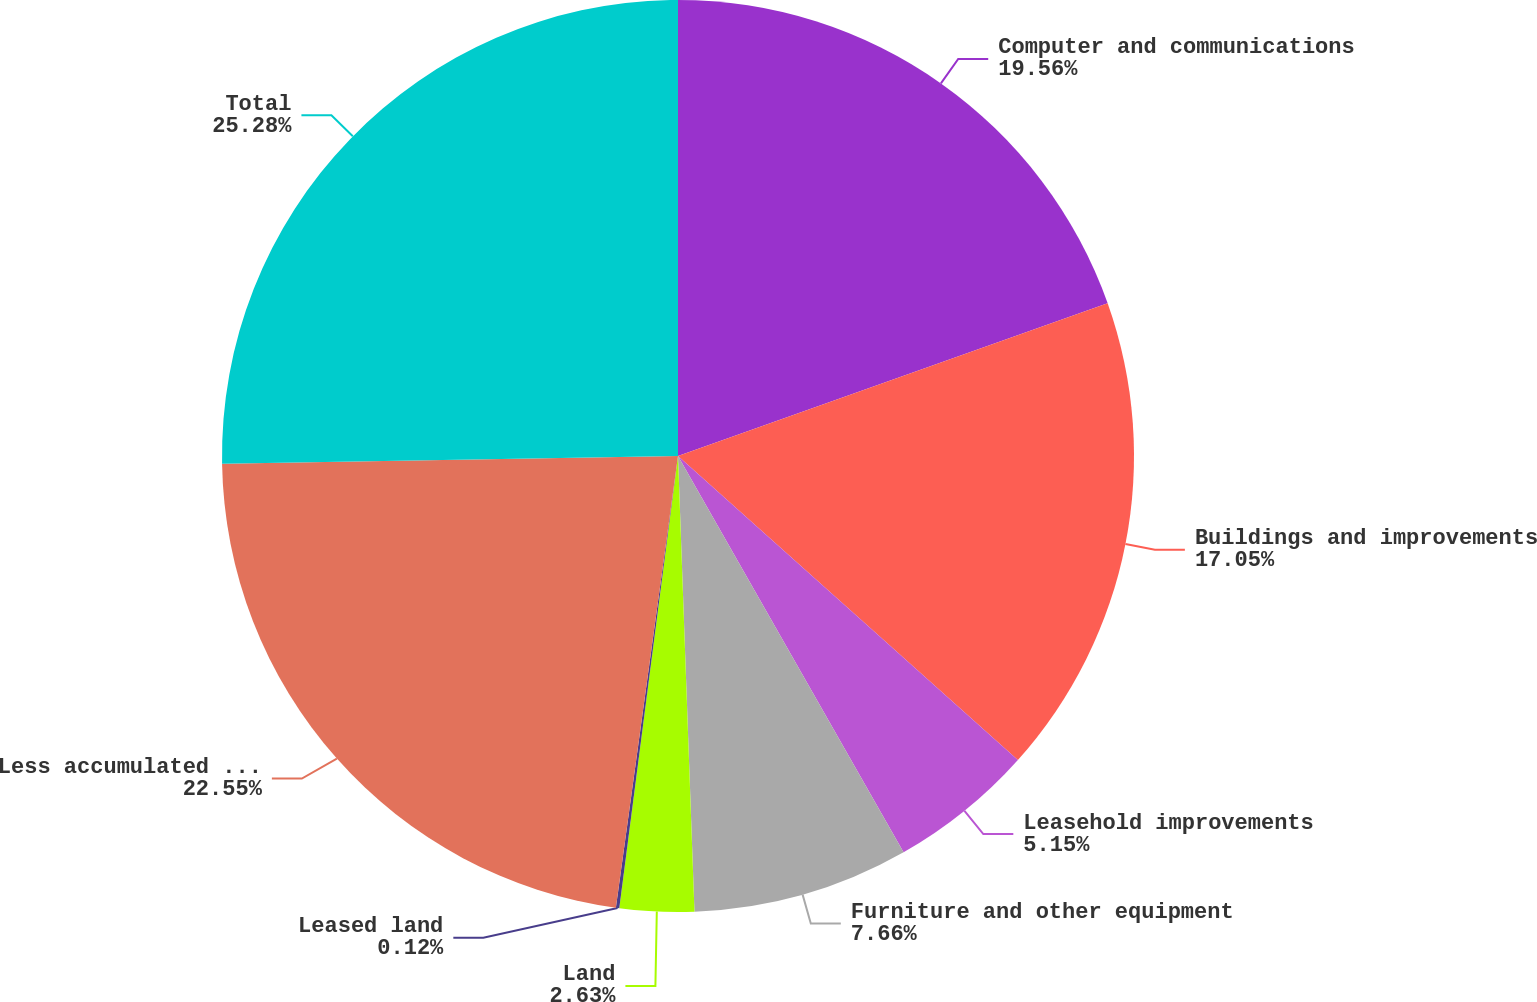<chart> <loc_0><loc_0><loc_500><loc_500><pie_chart><fcel>Computer and communications<fcel>Buildings and improvements<fcel>Leasehold improvements<fcel>Furniture and other equipment<fcel>Land<fcel>Leased land<fcel>Less accumulated depreciation<fcel>Total<nl><fcel>19.56%<fcel>17.05%<fcel>5.15%<fcel>7.66%<fcel>2.63%<fcel>0.12%<fcel>22.55%<fcel>25.27%<nl></chart> 